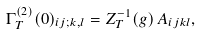<formula> <loc_0><loc_0><loc_500><loc_500>\Gamma _ { T } ^ { ( 2 ) } ( 0 ) _ { i j ; k , l } = Z _ { T } ^ { - 1 } ( g ) \, A _ { i j k l } ,</formula> 